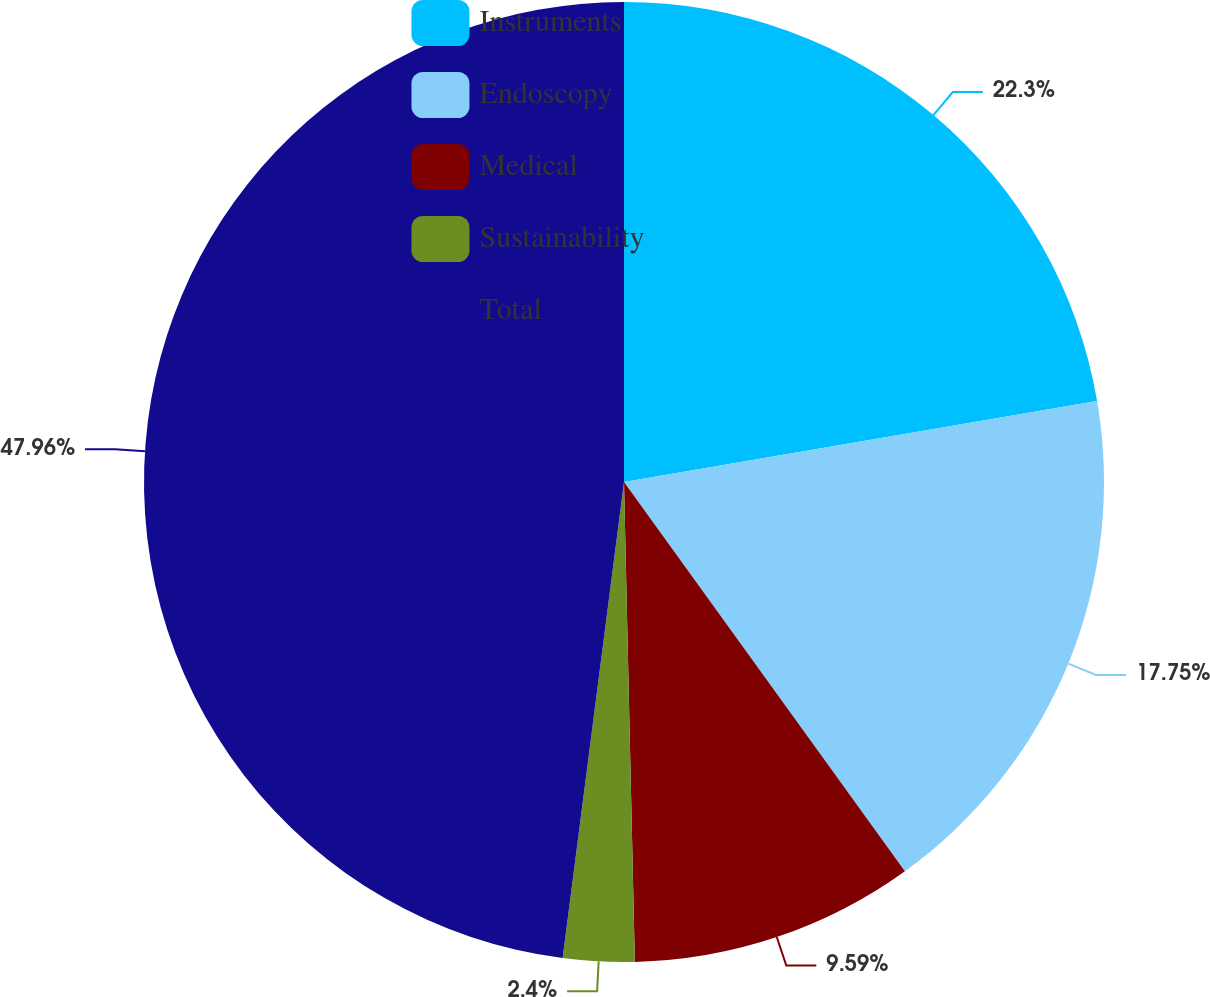<chart> <loc_0><loc_0><loc_500><loc_500><pie_chart><fcel>Instruments<fcel>Endoscopy<fcel>Medical<fcel>Sustainability<fcel>Total<nl><fcel>22.3%<fcel>17.75%<fcel>9.59%<fcel>2.4%<fcel>47.96%<nl></chart> 